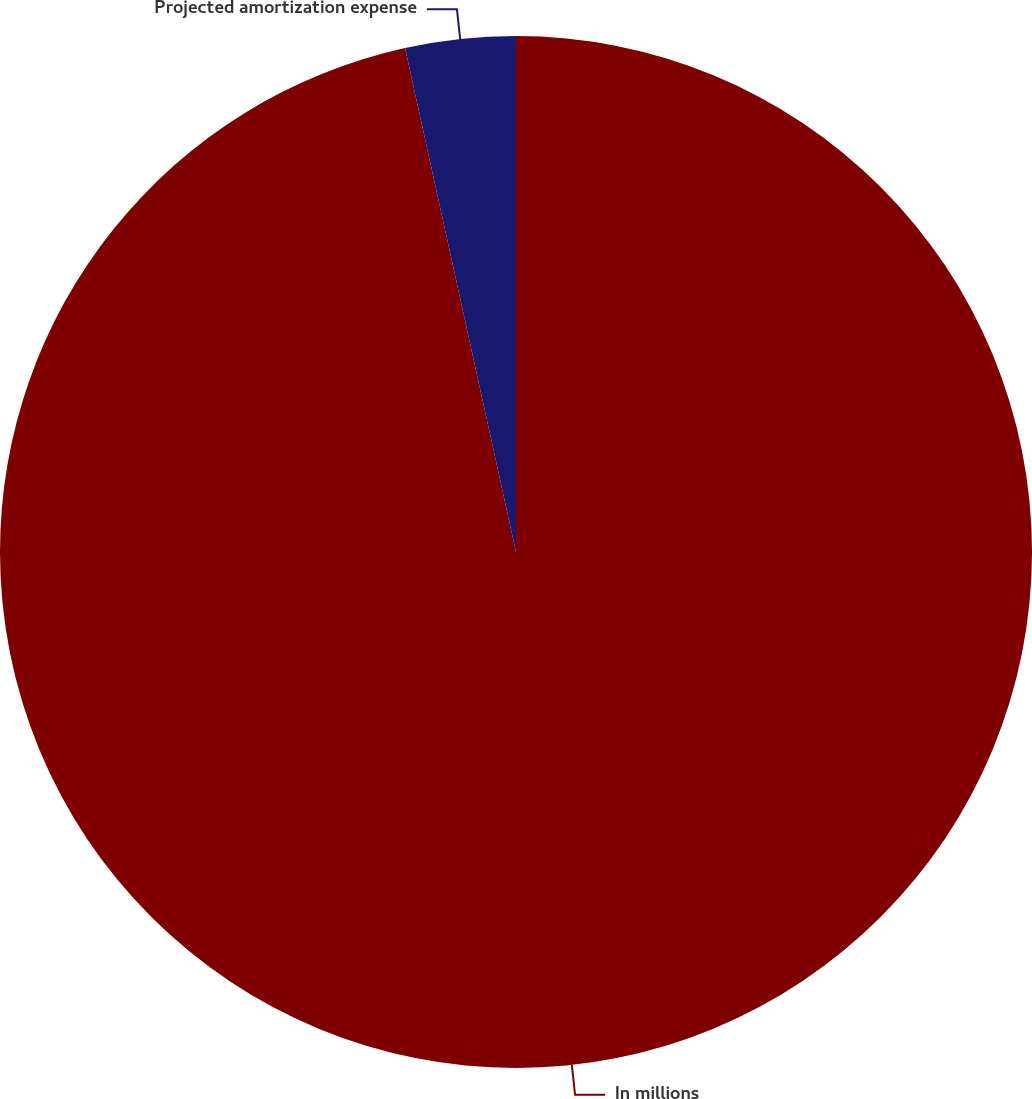<chart> <loc_0><loc_0><loc_500><loc_500><pie_chart><fcel>In millions<fcel>Projected amortization expense<nl><fcel>96.55%<fcel>3.45%<nl></chart> 